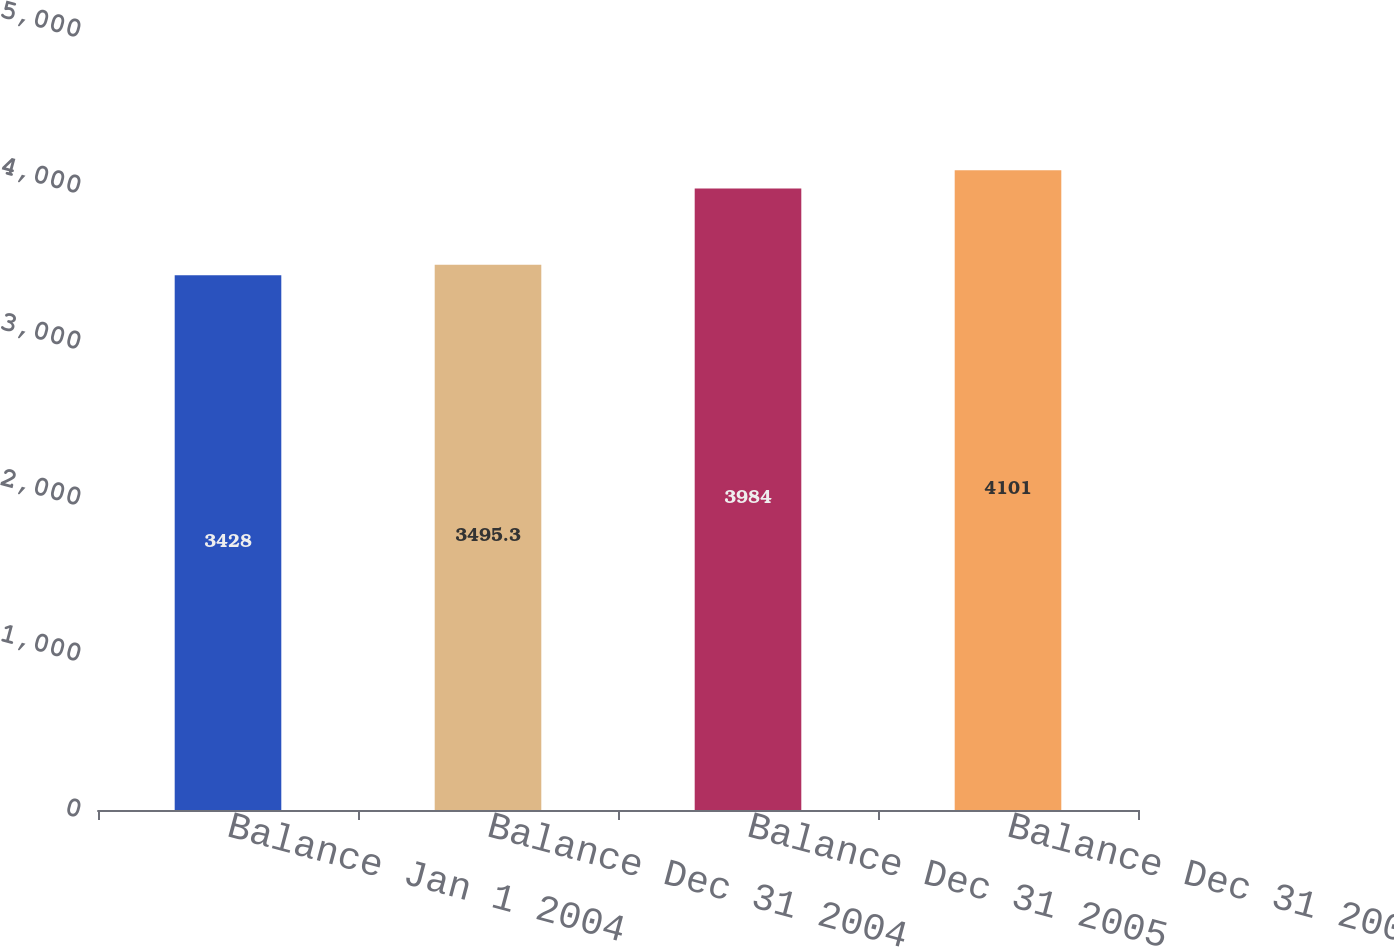Convert chart to OTSL. <chart><loc_0><loc_0><loc_500><loc_500><bar_chart><fcel>Balance Jan 1 2004<fcel>Balance Dec 31 2004<fcel>Balance Dec 31 2005<fcel>Balance Dec 31 2006<nl><fcel>3428<fcel>3495.3<fcel>3984<fcel>4101<nl></chart> 